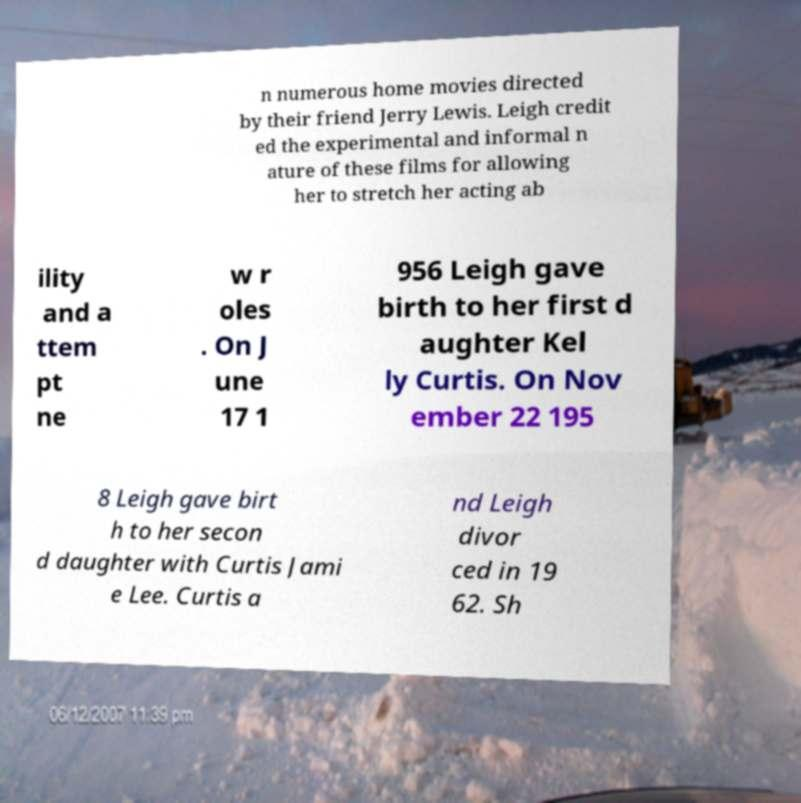Please identify and transcribe the text found in this image. n numerous home movies directed by their friend Jerry Lewis. Leigh credit ed the experimental and informal n ature of these films for allowing her to stretch her acting ab ility and a ttem pt ne w r oles . On J une 17 1 956 Leigh gave birth to her first d aughter Kel ly Curtis. On Nov ember 22 195 8 Leigh gave birt h to her secon d daughter with Curtis Jami e Lee. Curtis a nd Leigh divor ced in 19 62. Sh 